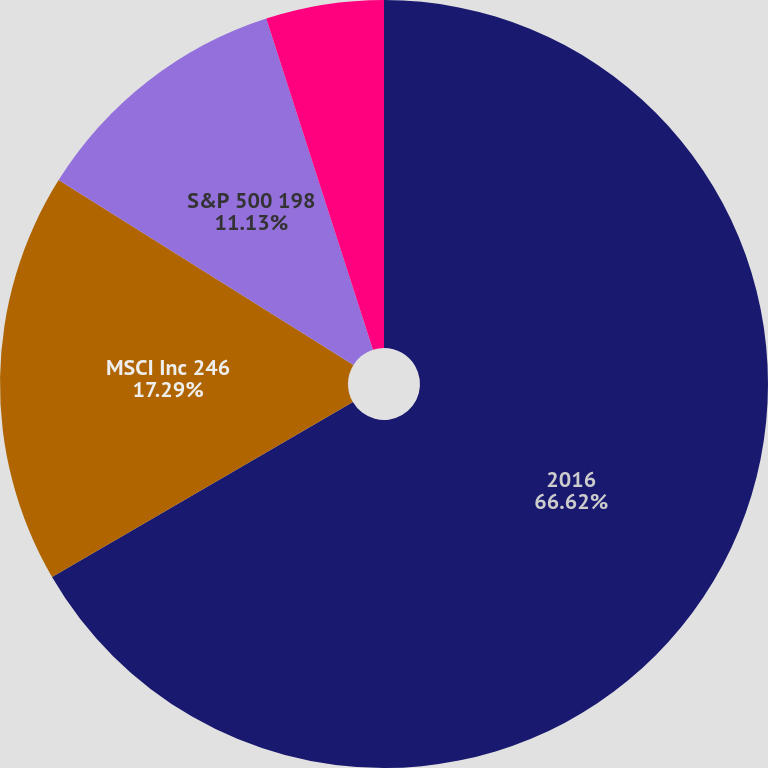Convert chart to OTSL. <chart><loc_0><loc_0><loc_500><loc_500><pie_chart><fcel>2016<fcel>MSCI Inc 246<fcel>S&P 500 198<fcel>NYSE Composite Index 168<nl><fcel>66.62%<fcel>17.29%<fcel>11.13%<fcel>4.96%<nl></chart> 